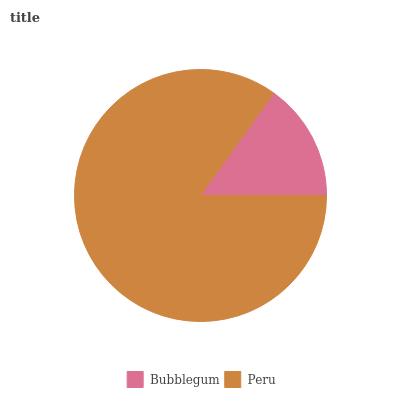Is Bubblegum the minimum?
Answer yes or no. Yes. Is Peru the maximum?
Answer yes or no. Yes. Is Peru the minimum?
Answer yes or no. No. Is Peru greater than Bubblegum?
Answer yes or no. Yes. Is Bubblegum less than Peru?
Answer yes or no. Yes. Is Bubblegum greater than Peru?
Answer yes or no. No. Is Peru less than Bubblegum?
Answer yes or no. No. Is Peru the high median?
Answer yes or no. Yes. Is Bubblegum the low median?
Answer yes or no. Yes. Is Bubblegum the high median?
Answer yes or no. No. Is Peru the low median?
Answer yes or no. No. 